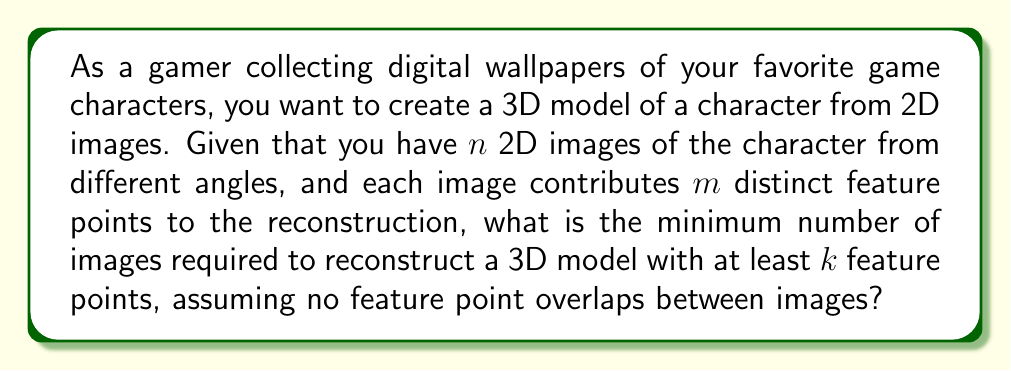Can you solve this math problem? Let's approach this step-by-step:

1) Each 2D image contributes $m$ distinct feature points to the 3D reconstruction.

2) We need at least $k$ feature points to create a satisfactory 3D model.

3) Since there's no overlap between feature points from different images, we can use a simple division to find the number of images needed:

   $$\text{Number of images} = \left\lceil\frac{k}{m}\right\rceil$$

   Where $\left\lceil \cdot \right\rceil$ represents the ceiling function, which rounds up to the nearest integer.

4) This ceiling function is necessary because we can only use whole images. If the division results in a fractional number, we need to round up to ensure we have at least $k$ feature points.

5) For example, if we need $k = 1000$ feature points and each image provides $m = 250$ points:

   $$\text{Number of images} = \left\lceil\frac{1000}{250}\right\rceil = \left\lceil4\right\rceil = 4$$

   So we would need 4 images to get at least 1000 feature points.
Answer: $$\left\lceil\frac{k}{m}\right\rceil$$ 